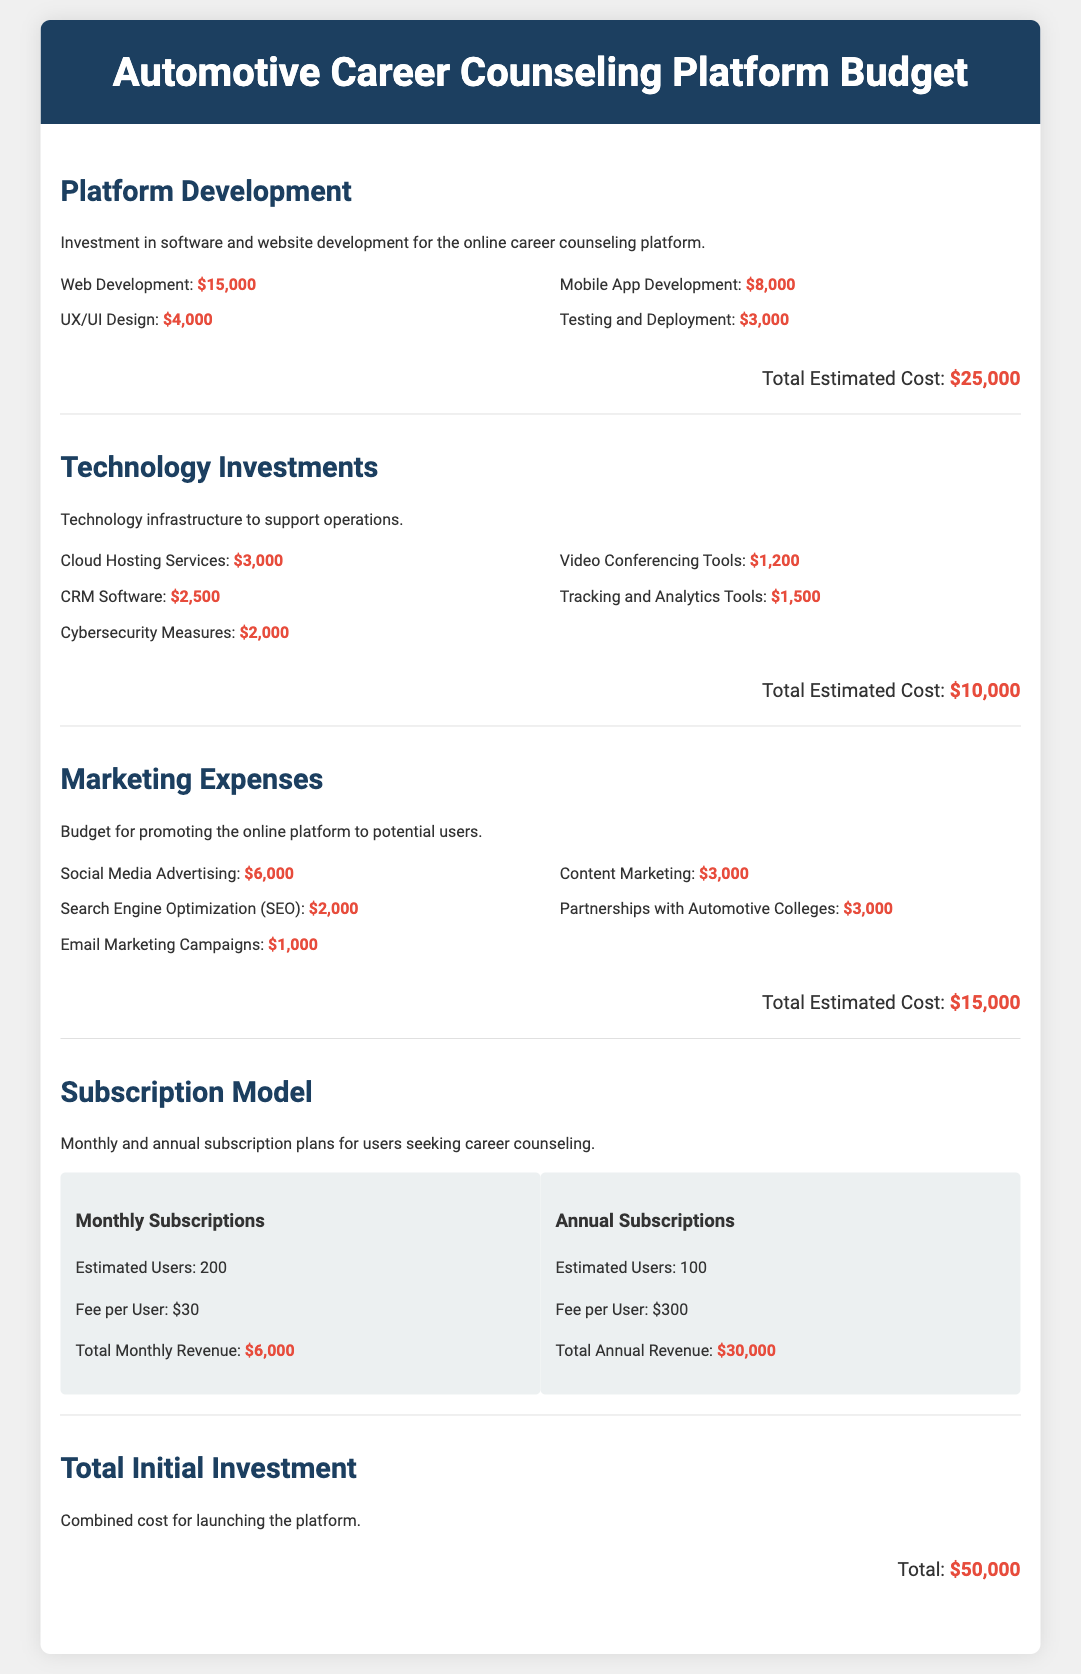what is the total estimated cost for platform development? The total estimated cost for platform development is calculated by adding all individual costs listed under this section.
Answer: $25,000 what is the cost of CRM software? The cost of CRM software is specified in the Technology Investments section.
Answer: $2,500 how much is allocated for social media advertising? The amount allocated for social media advertising is part of the Marketing Expenses.
Answer: $6,000 what is the total initial investment for the platform? The total initial investment for launching the platform is provided in the Total Initial Investment section.
Answer: $50,000 how many estimated users are for annual subscriptions? The document specifies the number of estimated users for annual subscriptions in the Subscription Model section.
Answer: 100 what is the fee per user for monthly subscriptions? The fee per user for monthly subscriptions is mentioned in the Subscription Model section.
Answer: $30 what is the total estimated cost for technology investments? The total estimated cost for technology investments is found by summing the costs listed under this section.
Answer: $10,000 which category has the highest individual cost? The category with the highest individual cost is determined by comparing costs within the sections of the document.
Answer: Web Development how much is budgeted for email marketing campaigns? The budget for email marketing campaigns can be found in the Marketing Expenses section of the document.
Answer: $1,000 what is included in the subscription model for revenue generation? The Subscription Model section provides details on different plans that generate revenue.
Answer: Monthly and Annual Subscriptions 